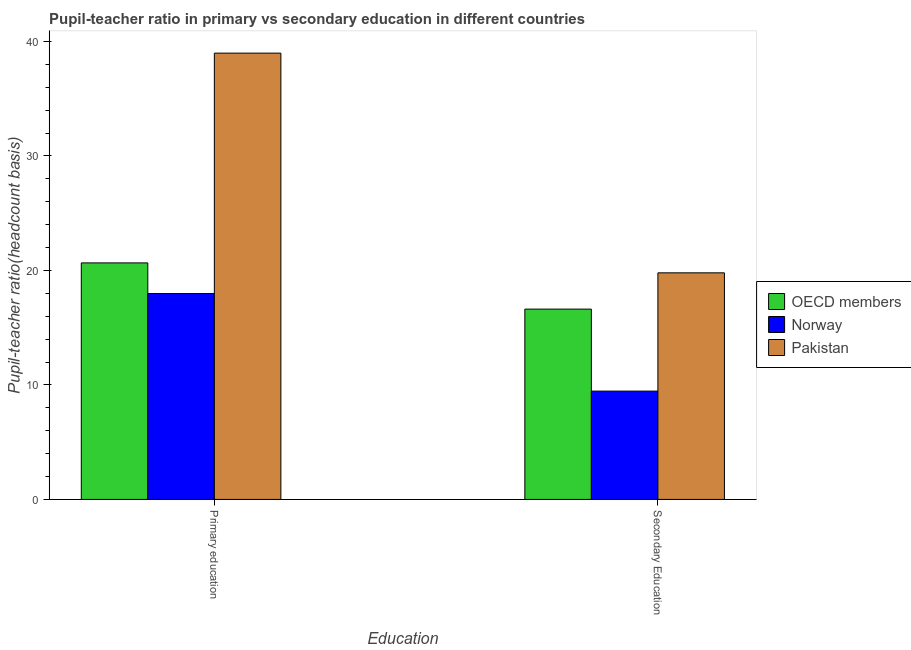How many groups of bars are there?
Your answer should be very brief. 2. How many bars are there on the 2nd tick from the right?
Offer a terse response. 3. What is the label of the 1st group of bars from the left?
Your response must be concise. Primary education. What is the pupil teacher ratio on secondary education in Norway?
Your answer should be compact. 9.46. Across all countries, what is the maximum pupil-teacher ratio in primary education?
Ensure brevity in your answer.  38.98. Across all countries, what is the minimum pupil-teacher ratio in primary education?
Provide a succinct answer. 17.99. What is the total pupil-teacher ratio in primary education in the graph?
Keep it short and to the point. 77.63. What is the difference between the pupil-teacher ratio in primary education in OECD members and that in Pakistan?
Keep it short and to the point. -18.32. What is the difference between the pupil teacher ratio on secondary education in Pakistan and the pupil-teacher ratio in primary education in OECD members?
Your response must be concise. -0.87. What is the average pupil teacher ratio on secondary education per country?
Provide a short and direct response. 15.29. What is the difference between the pupil-teacher ratio in primary education and pupil teacher ratio on secondary education in Pakistan?
Your answer should be very brief. 19.19. What is the ratio of the pupil-teacher ratio in primary education in Pakistan to that in Norway?
Make the answer very short. 2.17. In how many countries, is the pupil-teacher ratio in primary education greater than the average pupil-teacher ratio in primary education taken over all countries?
Your answer should be very brief. 1. What does the 3rd bar from the left in Primary education represents?
Your response must be concise. Pakistan. What does the 1st bar from the right in Primary education represents?
Your response must be concise. Pakistan. Are all the bars in the graph horizontal?
Your answer should be compact. No. How many countries are there in the graph?
Your answer should be compact. 3. Are the values on the major ticks of Y-axis written in scientific E-notation?
Make the answer very short. No. How many legend labels are there?
Ensure brevity in your answer.  3. What is the title of the graph?
Your response must be concise. Pupil-teacher ratio in primary vs secondary education in different countries. Does "Belarus" appear as one of the legend labels in the graph?
Offer a terse response. No. What is the label or title of the X-axis?
Provide a succinct answer. Education. What is the label or title of the Y-axis?
Offer a terse response. Pupil-teacher ratio(headcount basis). What is the Pupil-teacher ratio(headcount basis) in OECD members in Primary education?
Offer a very short reply. 20.66. What is the Pupil-teacher ratio(headcount basis) of Norway in Primary education?
Offer a terse response. 17.99. What is the Pupil-teacher ratio(headcount basis) in Pakistan in Primary education?
Provide a short and direct response. 38.98. What is the Pupil-teacher ratio(headcount basis) in OECD members in Secondary Education?
Offer a very short reply. 16.62. What is the Pupil-teacher ratio(headcount basis) of Norway in Secondary Education?
Provide a short and direct response. 9.46. What is the Pupil-teacher ratio(headcount basis) in Pakistan in Secondary Education?
Your answer should be compact. 19.79. Across all Education, what is the maximum Pupil-teacher ratio(headcount basis) in OECD members?
Your answer should be compact. 20.66. Across all Education, what is the maximum Pupil-teacher ratio(headcount basis) in Norway?
Your answer should be compact. 17.99. Across all Education, what is the maximum Pupil-teacher ratio(headcount basis) in Pakistan?
Offer a very short reply. 38.98. Across all Education, what is the minimum Pupil-teacher ratio(headcount basis) of OECD members?
Your answer should be compact. 16.62. Across all Education, what is the minimum Pupil-teacher ratio(headcount basis) in Norway?
Your answer should be very brief. 9.46. Across all Education, what is the minimum Pupil-teacher ratio(headcount basis) of Pakistan?
Your response must be concise. 19.79. What is the total Pupil-teacher ratio(headcount basis) of OECD members in the graph?
Keep it short and to the point. 37.28. What is the total Pupil-teacher ratio(headcount basis) in Norway in the graph?
Provide a succinct answer. 27.45. What is the total Pupil-teacher ratio(headcount basis) in Pakistan in the graph?
Your answer should be very brief. 58.77. What is the difference between the Pupil-teacher ratio(headcount basis) in OECD members in Primary education and that in Secondary Education?
Make the answer very short. 4.04. What is the difference between the Pupil-teacher ratio(headcount basis) of Norway in Primary education and that in Secondary Education?
Keep it short and to the point. 8.52. What is the difference between the Pupil-teacher ratio(headcount basis) of Pakistan in Primary education and that in Secondary Education?
Offer a terse response. 19.19. What is the difference between the Pupil-teacher ratio(headcount basis) in OECD members in Primary education and the Pupil-teacher ratio(headcount basis) in Norway in Secondary Education?
Offer a very short reply. 11.2. What is the difference between the Pupil-teacher ratio(headcount basis) of OECD members in Primary education and the Pupil-teacher ratio(headcount basis) of Pakistan in Secondary Education?
Ensure brevity in your answer.  0.87. What is the difference between the Pupil-teacher ratio(headcount basis) in Norway in Primary education and the Pupil-teacher ratio(headcount basis) in Pakistan in Secondary Education?
Provide a succinct answer. -1.81. What is the average Pupil-teacher ratio(headcount basis) in OECD members per Education?
Offer a very short reply. 18.64. What is the average Pupil-teacher ratio(headcount basis) in Norway per Education?
Provide a succinct answer. 13.72. What is the average Pupil-teacher ratio(headcount basis) of Pakistan per Education?
Give a very brief answer. 29.39. What is the difference between the Pupil-teacher ratio(headcount basis) in OECD members and Pupil-teacher ratio(headcount basis) in Norway in Primary education?
Your answer should be compact. 2.67. What is the difference between the Pupil-teacher ratio(headcount basis) of OECD members and Pupil-teacher ratio(headcount basis) of Pakistan in Primary education?
Ensure brevity in your answer.  -18.32. What is the difference between the Pupil-teacher ratio(headcount basis) of Norway and Pupil-teacher ratio(headcount basis) of Pakistan in Primary education?
Keep it short and to the point. -21. What is the difference between the Pupil-teacher ratio(headcount basis) of OECD members and Pupil-teacher ratio(headcount basis) of Norway in Secondary Education?
Provide a succinct answer. 7.16. What is the difference between the Pupil-teacher ratio(headcount basis) in OECD members and Pupil-teacher ratio(headcount basis) in Pakistan in Secondary Education?
Your answer should be compact. -3.17. What is the difference between the Pupil-teacher ratio(headcount basis) in Norway and Pupil-teacher ratio(headcount basis) in Pakistan in Secondary Education?
Provide a short and direct response. -10.33. What is the ratio of the Pupil-teacher ratio(headcount basis) of OECD members in Primary education to that in Secondary Education?
Offer a terse response. 1.24. What is the ratio of the Pupil-teacher ratio(headcount basis) in Norway in Primary education to that in Secondary Education?
Keep it short and to the point. 1.9. What is the ratio of the Pupil-teacher ratio(headcount basis) of Pakistan in Primary education to that in Secondary Education?
Provide a succinct answer. 1.97. What is the difference between the highest and the second highest Pupil-teacher ratio(headcount basis) in OECD members?
Your answer should be compact. 4.04. What is the difference between the highest and the second highest Pupil-teacher ratio(headcount basis) in Norway?
Keep it short and to the point. 8.52. What is the difference between the highest and the second highest Pupil-teacher ratio(headcount basis) in Pakistan?
Your answer should be compact. 19.19. What is the difference between the highest and the lowest Pupil-teacher ratio(headcount basis) in OECD members?
Offer a very short reply. 4.04. What is the difference between the highest and the lowest Pupil-teacher ratio(headcount basis) of Norway?
Your response must be concise. 8.52. What is the difference between the highest and the lowest Pupil-teacher ratio(headcount basis) of Pakistan?
Make the answer very short. 19.19. 